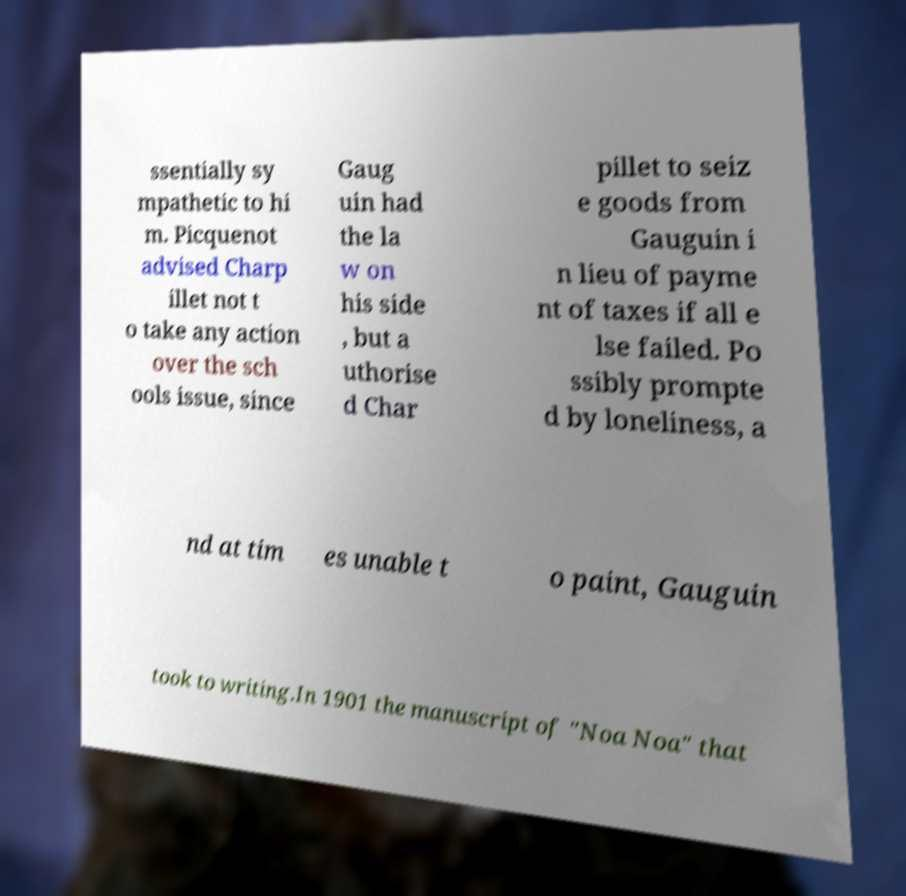I need the written content from this picture converted into text. Can you do that? ssentially sy mpathetic to hi m. Picquenot advised Charp illet not t o take any action over the sch ools issue, since Gaug uin had the la w on his side , but a uthorise d Char pillet to seiz e goods from Gauguin i n lieu of payme nt of taxes if all e lse failed. Po ssibly prompte d by loneliness, a nd at tim es unable t o paint, Gauguin took to writing.In 1901 the manuscript of "Noa Noa" that 